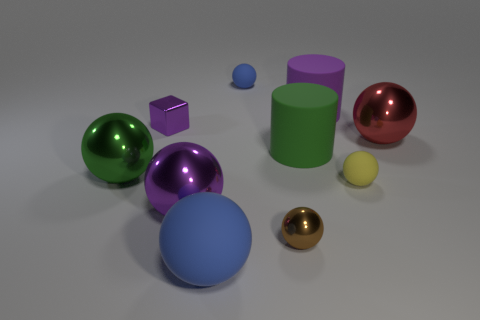Subtract all brown cylinders. How many blue spheres are left? 2 Subtract all shiny spheres. How many spheres are left? 3 Subtract all green spheres. How many spheres are left? 6 Subtract 4 balls. How many balls are left? 3 Subtract all cylinders. How many objects are left? 8 Subtract all green balls. Subtract all gray cubes. How many balls are left? 6 Subtract 0 blue blocks. How many objects are left? 10 Subtract all small yellow rubber spheres. Subtract all big green balls. How many objects are left? 8 Add 4 purple matte things. How many purple matte things are left? 5 Add 2 green shiny things. How many green shiny things exist? 3 